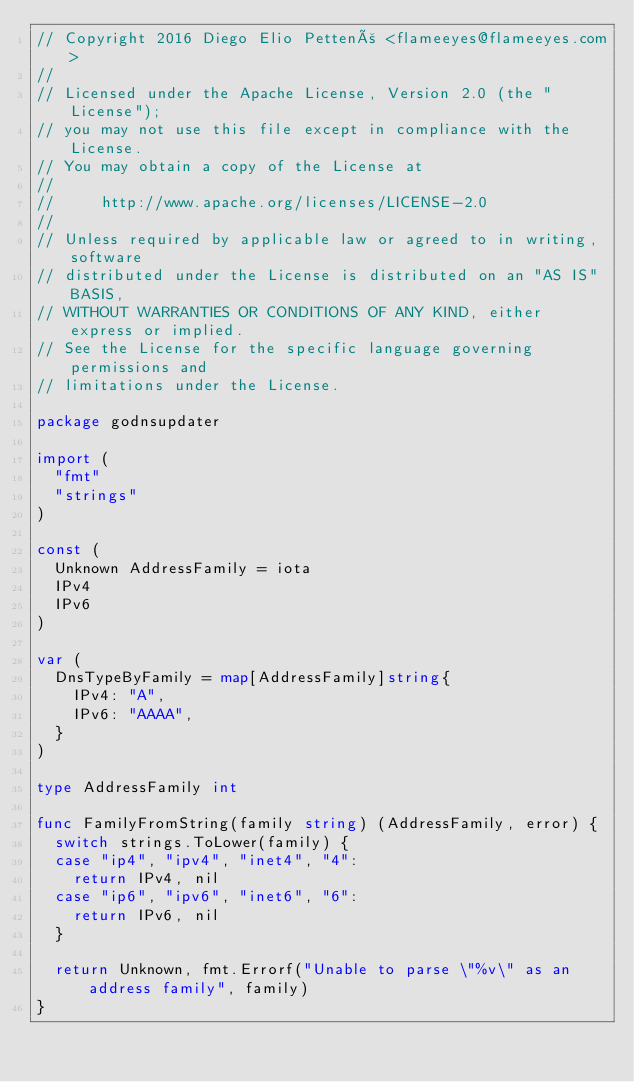Convert code to text. <code><loc_0><loc_0><loc_500><loc_500><_Go_>// Copyright 2016 Diego Elio Pettenò <flameeyes@flameeyes.com>
//
// Licensed under the Apache License, Version 2.0 (the "License");
// you may not use this file except in compliance with the License.
// You may obtain a copy of the License at
//
//     http://www.apache.org/licenses/LICENSE-2.0
//
// Unless required by applicable law or agreed to in writing, software
// distributed under the License is distributed on an "AS IS" BASIS,
// WITHOUT WARRANTIES OR CONDITIONS OF ANY KIND, either express or implied.
// See the License for the specific language governing permissions and
// limitations under the License.

package godnsupdater

import (
	"fmt"
	"strings"
)

const (
	Unknown AddressFamily = iota
	IPv4
	IPv6
)

var (
	DnsTypeByFamily = map[AddressFamily]string{
		IPv4: "A",
		IPv6: "AAAA",
	}
)

type AddressFamily int

func FamilyFromString(family string) (AddressFamily, error) {
	switch strings.ToLower(family) {
	case "ip4", "ipv4", "inet4", "4":
		return IPv4, nil
	case "ip6", "ipv6", "inet6", "6":
		return IPv6, nil
	}

	return Unknown, fmt.Errorf("Unable to parse \"%v\" as an address family", family)
}
</code> 